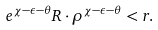Convert formula to latex. <formula><loc_0><loc_0><loc_500><loc_500>e ^ { \chi - \epsilon - \theta } R \cdot \rho ^ { \chi - \epsilon - \theta } < r .</formula> 